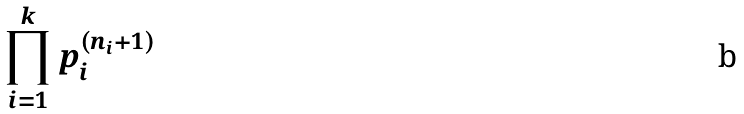Convert formula to latex. <formula><loc_0><loc_0><loc_500><loc_500>\prod _ { i = 1 } ^ { k } p _ { i } ^ { ( n _ { i } + 1 ) }</formula> 